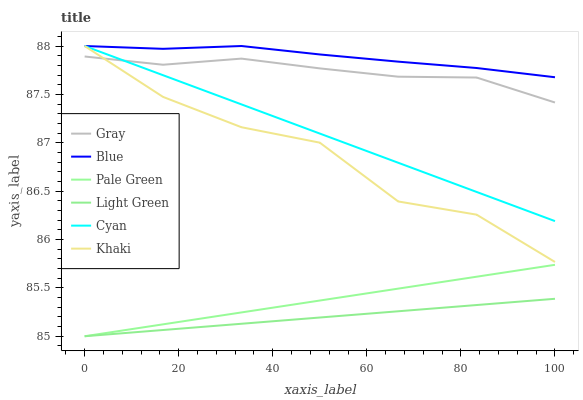Does Light Green have the minimum area under the curve?
Answer yes or no. Yes. Does Blue have the maximum area under the curve?
Answer yes or no. Yes. Does Gray have the minimum area under the curve?
Answer yes or no. No. Does Gray have the maximum area under the curve?
Answer yes or no. No. Is Pale Green the smoothest?
Answer yes or no. Yes. Is Khaki the roughest?
Answer yes or no. Yes. Is Gray the smoothest?
Answer yes or no. No. Is Gray the roughest?
Answer yes or no. No. Does Pale Green have the lowest value?
Answer yes or no. Yes. Does Gray have the lowest value?
Answer yes or no. No. Does Cyan have the highest value?
Answer yes or no. Yes. Does Gray have the highest value?
Answer yes or no. No. Is Pale Green less than Gray?
Answer yes or no. Yes. Is Blue greater than Pale Green?
Answer yes or no. Yes. Does Gray intersect Khaki?
Answer yes or no. Yes. Is Gray less than Khaki?
Answer yes or no. No. Is Gray greater than Khaki?
Answer yes or no. No. Does Pale Green intersect Gray?
Answer yes or no. No. 